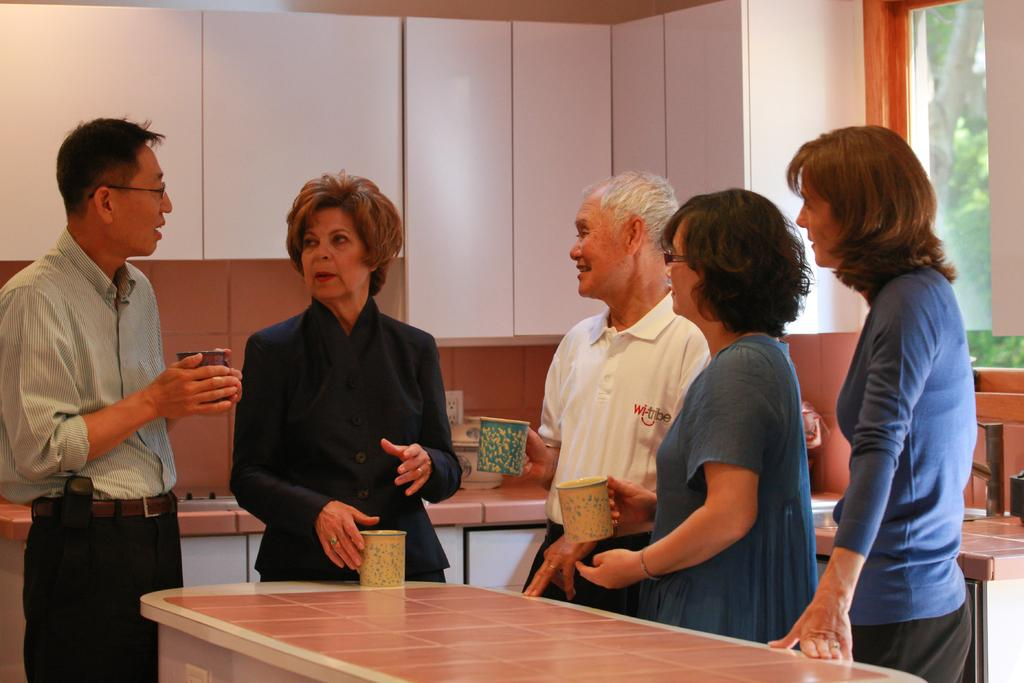How many people are in the image? There are five people in the image, two men and three women. What are the people in the image doing? The people are standing. What can be seen on the table in the image? There is a cup on a table. What can be seen on the desk in the image? There is a bowl on a desk. What is visible in the background of the image? There are cupboards and trees in the background. What type of cub is playing with the women in the image? There is no cub present in the image. What emotions are the people feeling in the image? The image does not provide information about the emotions of the people. What songs are the men singing in the image? There is no indication in the image that the men are singing any songs. 